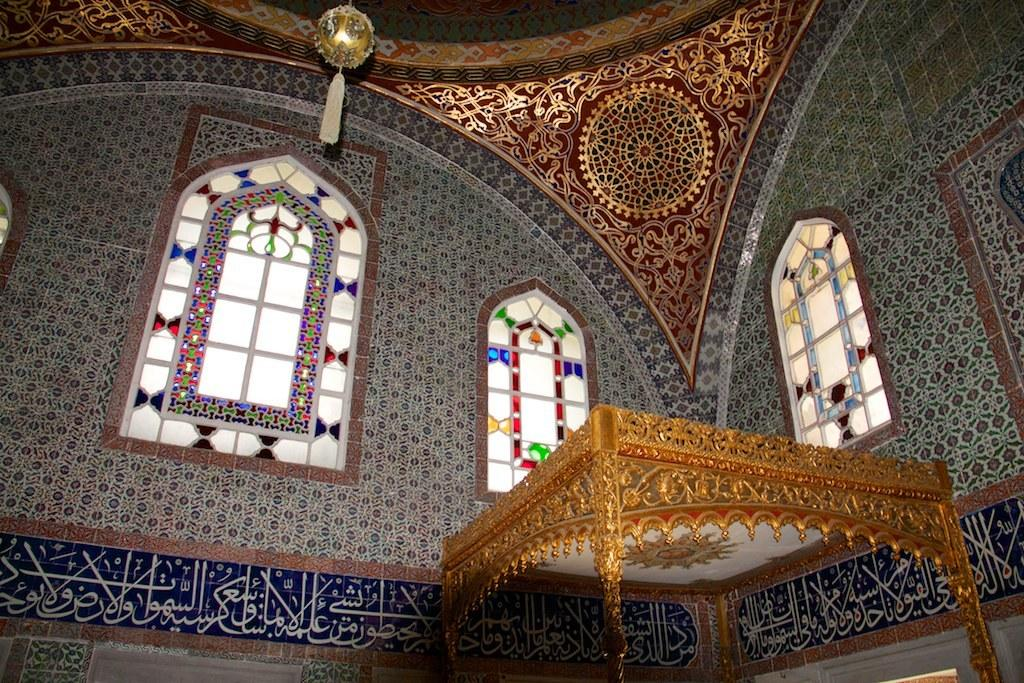What type of building is shown in the image? The image depicts the interior of a mosque. What feature can be seen in the mosque that allows natural light to enter? There are big windows in the mosque. What type of writing is present on the walls of the mosque? Arabic writing is present on the walls. Where can the chicken be found in the image? There is no chicken present in the image. What type of juice is being served in the mosque? There is no juice or any indication of food or drink in the image. 